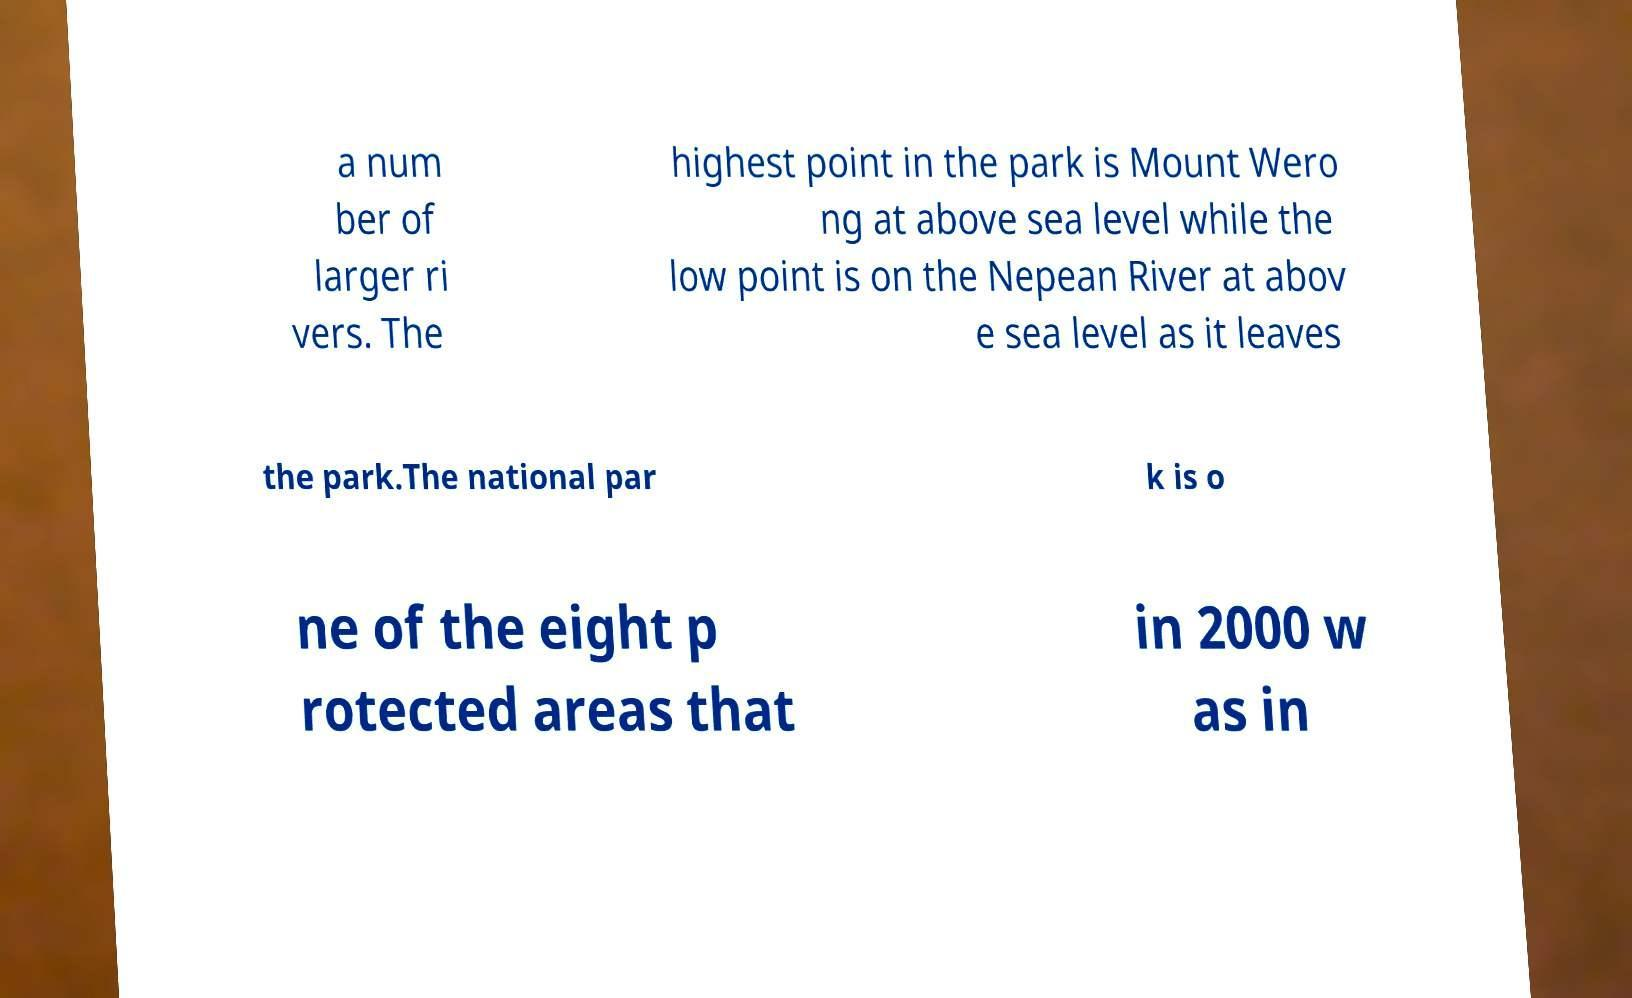There's text embedded in this image that I need extracted. Can you transcribe it verbatim? a num ber of larger ri vers. The highest point in the park is Mount Wero ng at above sea level while the low point is on the Nepean River at abov e sea level as it leaves the park.The national par k is o ne of the eight p rotected areas that in 2000 w as in 